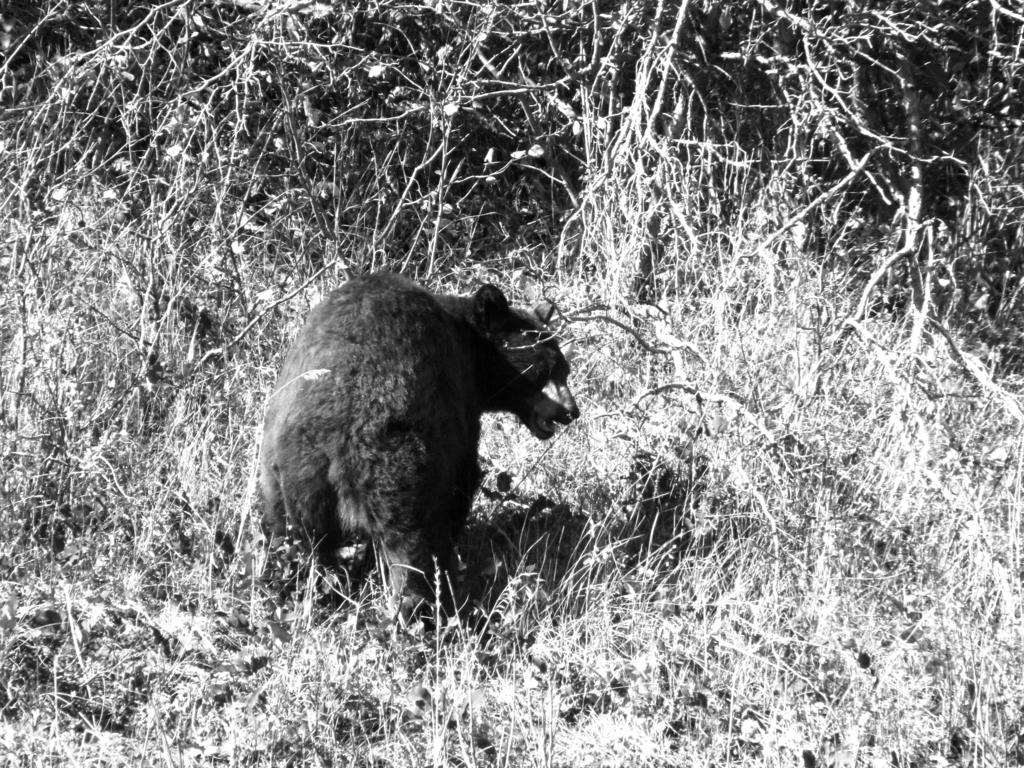What is the color scheme of the image? The image is black and white. What type of living organisms can be seen in the image? There are plants in the image. What is the main subject in the middle of the image? There is a bear in the middle of the image. Can you tell me how many beans are scattered around the bear in the image? There are no beans present in the image; it features a bear and plants in a black and white setting. Is there a stream visible in the image? There is no stream present in the image; it only features a bear and plants in a black and white setting. 